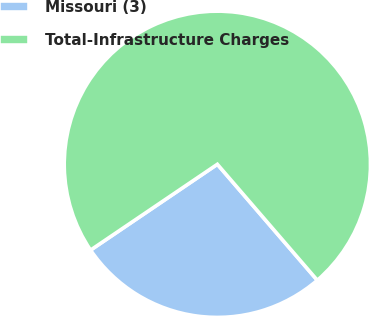Convert chart. <chart><loc_0><loc_0><loc_500><loc_500><pie_chart><fcel>Missouri (3)<fcel>Total-Infrastructure Charges<nl><fcel>26.85%<fcel>73.15%<nl></chart> 